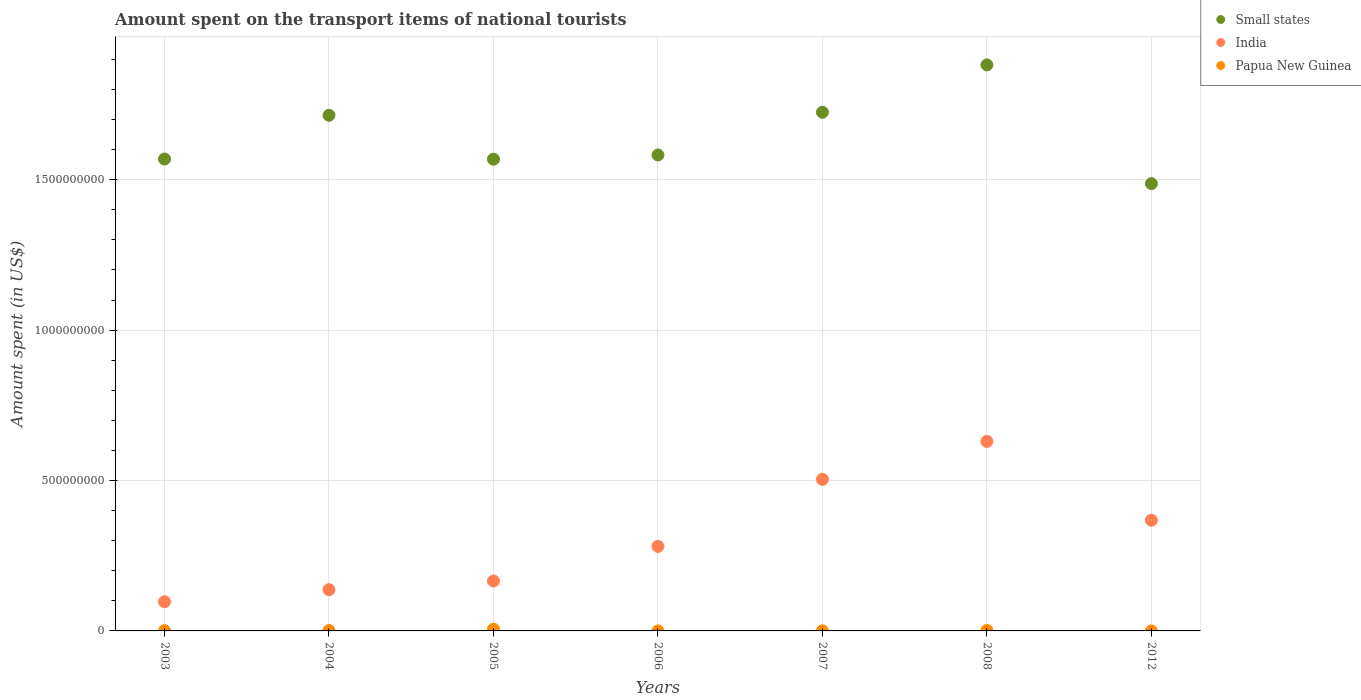What is the amount spent on the transport items of national tourists in India in 2008?
Your response must be concise. 6.30e+08. Across all years, what is the maximum amount spent on the transport items of national tourists in Papua New Guinea?
Give a very brief answer. 5.80e+06. Across all years, what is the minimum amount spent on the transport items of national tourists in Small states?
Provide a succinct answer. 1.49e+09. In which year was the amount spent on the transport items of national tourists in Small states minimum?
Offer a terse response. 2012. What is the total amount spent on the transport items of national tourists in Small states in the graph?
Your answer should be compact. 1.15e+1. What is the difference between the amount spent on the transport items of national tourists in India in 2006 and that in 2008?
Ensure brevity in your answer.  -3.49e+08. What is the difference between the amount spent on the transport items of national tourists in India in 2003 and the amount spent on the transport items of national tourists in Papua New Guinea in 2007?
Ensure brevity in your answer.  9.67e+07. What is the average amount spent on the transport items of national tourists in India per year?
Offer a very short reply. 3.12e+08. In the year 2005, what is the difference between the amount spent on the transport items of national tourists in Papua New Guinea and amount spent on the transport items of national tourists in India?
Offer a very short reply. -1.60e+08. In how many years, is the amount spent on the transport items of national tourists in Small states greater than 100000000 US$?
Provide a short and direct response. 7. What is the ratio of the amount spent on the transport items of national tourists in Small states in 2004 to that in 2006?
Your answer should be compact. 1.08. Is the difference between the amount spent on the transport items of national tourists in Papua New Guinea in 2007 and 2008 greater than the difference between the amount spent on the transport items of national tourists in India in 2007 and 2008?
Offer a very short reply. Yes. What is the difference between the highest and the second highest amount spent on the transport items of national tourists in Papua New Guinea?
Provide a short and direct response. 4.20e+06. What is the difference between the highest and the lowest amount spent on the transport items of national tourists in Papua New Guinea?
Provide a short and direct response. 5.77e+06. In how many years, is the amount spent on the transport items of national tourists in Papua New Guinea greater than the average amount spent on the transport items of national tourists in Papua New Guinea taken over all years?
Offer a very short reply. 2. Is it the case that in every year, the sum of the amount spent on the transport items of national tourists in Papua New Guinea and amount spent on the transport items of national tourists in India  is greater than the amount spent on the transport items of national tourists in Small states?
Provide a short and direct response. No. What is the difference between two consecutive major ticks on the Y-axis?
Provide a succinct answer. 5.00e+08. Are the values on the major ticks of Y-axis written in scientific E-notation?
Offer a terse response. No. Where does the legend appear in the graph?
Provide a succinct answer. Top right. How are the legend labels stacked?
Keep it short and to the point. Vertical. What is the title of the graph?
Provide a short and direct response. Amount spent on the transport items of national tourists. Does "Heavily indebted poor countries" appear as one of the legend labels in the graph?
Offer a terse response. No. What is the label or title of the Y-axis?
Ensure brevity in your answer.  Amount spent (in US$). What is the Amount spent (in US$) in Small states in 2003?
Offer a terse response. 1.57e+09. What is the Amount spent (in US$) in India in 2003?
Your answer should be very brief. 9.70e+07. What is the Amount spent (in US$) in Papua New Guinea in 2003?
Provide a short and direct response. 9.00e+05. What is the Amount spent (in US$) in Small states in 2004?
Make the answer very short. 1.71e+09. What is the Amount spent (in US$) of India in 2004?
Offer a terse response. 1.37e+08. What is the Amount spent (in US$) of Papua New Guinea in 2004?
Keep it short and to the point. 1.30e+06. What is the Amount spent (in US$) of Small states in 2005?
Offer a terse response. 1.57e+09. What is the Amount spent (in US$) of India in 2005?
Give a very brief answer. 1.66e+08. What is the Amount spent (in US$) of Papua New Guinea in 2005?
Keep it short and to the point. 5.80e+06. What is the Amount spent (in US$) in Small states in 2006?
Your answer should be compact. 1.58e+09. What is the Amount spent (in US$) of India in 2006?
Offer a very short reply. 2.81e+08. What is the Amount spent (in US$) of Papua New Guinea in 2006?
Offer a terse response. 3.00e+04. What is the Amount spent (in US$) of Small states in 2007?
Provide a succinct answer. 1.72e+09. What is the Amount spent (in US$) of India in 2007?
Your answer should be compact. 5.04e+08. What is the Amount spent (in US$) of Small states in 2008?
Your answer should be compact. 1.88e+09. What is the Amount spent (in US$) of India in 2008?
Ensure brevity in your answer.  6.30e+08. What is the Amount spent (in US$) of Papua New Guinea in 2008?
Your answer should be compact. 1.60e+06. What is the Amount spent (in US$) in Small states in 2012?
Provide a short and direct response. 1.49e+09. What is the Amount spent (in US$) in India in 2012?
Your response must be concise. 3.68e+08. Across all years, what is the maximum Amount spent (in US$) in Small states?
Keep it short and to the point. 1.88e+09. Across all years, what is the maximum Amount spent (in US$) of India?
Offer a terse response. 6.30e+08. Across all years, what is the maximum Amount spent (in US$) of Papua New Guinea?
Offer a very short reply. 5.80e+06. Across all years, what is the minimum Amount spent (in US$) of Small states?
Provide a short and direct response. 1.49e+09. Across all years, what is the minimum Amount spent (in US$) of India?
Keep it short and to the point. 9.70e+07. Across all years, what is the minimum Amount spent (in US$) of Papua New Guinea?
Offer a very short reply. 3.00e+04. What is the total Amount spent (in US$) of Small states in the graph?
Your answer should be compact. 1.15e+1. What is the total Amount spent (in US$) in India in the graph?
Give a very brief answer. 2.18e+09. What is the total Amount spent (in US$) in Papua New Guinea in the graph?
Provide a succinct answer. 1.00e+07. What is the difference between the Amount spent (in US$) of Small states in 2003 and that in 2004?
Offer a very short reply. -1.45e+08. What is the difference between the Amount spent (in US$) of India in 2003 and that in 2004?
Offer a very short reply. -4.00e+07. What is the difference between the Amount spent (in US$) in Papua New Guinea in 2003 and that in 2004?
Offer a very short reply. -4.00e+05. What is the difference between the Amount spent (in US$) of Small states in 2003 and that in 2005?
Ensure brevity in your answer.  5.74e+05. What is the difference between the Amount spent (in US$) of India in 2003 and that in 2005?
Give a very brief answer. -6.90e+07. What is the difference between the Amount spent (in US$) in Papua New Guinea in 2003 and that in 2005?
Keep it short and to the point. -4.90e+06. What is the difference between the Amount spent (in US$) in Small states in 2003 and that in 2006?
Keep it short and to the point. -1.35e+07. What is the difference between the Amount spent (in US$) of India in 2003 and that in 2006?
Ensure brevity in your answer.  -1.84e+08. What is the difference between the Amount spent (in US$) in Papua New Guinea in 2003 and that in 2006?
Your answer should be very brief. 8.70e+05. What is the difference between the Amount spent (in US$) in Small states in 2003 and that in 2007?
Your answer should be compact. -1.55e+08. What is the difference between the Amount spent (in US$) in India in 2003 and that in 2007?
Provide a succinct answer. -4.07e+08. What is the difference between the Amount spent (in US$) of Papua New Guinea in 2003 and that in 2007?
Your response must be concise. 6.00e+05. What is the difference between the Amount spent (in US$) of Small states in 2003 and that in 2008?
Keep it short and to the point. -3.13e+08. What is the difference between the Amount spent (in US$) in India in 2003 and that in 2008?
Offer a terse response. -5.33e+08. What is the difference between the Amount spent (in US$) in Papua New Guinea in 2003 and that in 2008?
Make the answer very short. -7.00e+05. What is the difference between the Amount spent (in US$) of Small states in 2003 and that in 2012?
Provide a short and direct response. 8.17e+07. What is the difference between the Amount spent (in US$) of India in 2003 and that in 2012?
Ensure brevity in your answer.  -2.71e+08. What is the difference between the Amount spent (in US$) in Papua New Guinea in 2003 and that in 2012?
Provide a short and direct response. 8.00e+05. What is the difference between the Amount spent (in US$) in Small states in 2004 and that in 2005?
Keep it short and to the point. 1.46e+08. What is the difference between the Amount spent (in US$) of India in 2004 and that in 2005?
Your response must be concise. -2.90e+07. What is the difference between the Amount spent (in US$) of Papua New Guinea in 2004 and that in 2005?
Ensure brevity in your answer.  -4.50e+06. What is the difference between the Amount spent (in US$) of Small states in 2004 and that in 2006?
Provide a short and direct response. 1.32e+08. What is the difference between the Amount spent (in US$) in India in 2004 and that in 2006?
Ensure brevity in your answer.  -1.44e+08. What is the difference between the Amount spent (in US$) in Papua New Guinea in 2004 and that in 2006?
Provide a succinct answer. 1.27e+06. What is the difference between the Amount spent (in US$) of Small states in 2004 and that in 2007?
Offer a terse response. -9.98e+06. What is the difference between the Amount spent (in US$) of India in 2004 and that in 2007?
Your answer should be very brief. -3.67e+08. What is the difference between the Amount spent (in US$) of Papua New Guinea in 2004 and that in 2007?
Offer a very short reply. 1.00e+06. What is the difference between the Amount spent (in US$) in Small states in 2004 and that in 2008?
Offer a terse response. -1.68e+08. What is the difference between the Amount spent (in US$) in India in 2004 and that in 2008?
Your response must be concise. -4.93e+08. What is the difference between the Amount spent (in US$) in Small states in 2004 and that in 2012?
Ensure brevity in your answer.  2.27e+08. What is the difference between the Amount spent (in US$) of India in 2004 and that in 2012?
Make the answer very short. -2.31e+08. What is the difference between the Amount spent (in US$) of Papua New Guinea in 2004 and that in 2012?
Your answer should be compact. 1.20e+06. What is the difference between the Amount spent (in US$) of Small states in 2005 and that in 2006?
Keep it short and to the point. -1.40e+07. What is the difference between the Amount spent (in US$) of India in 2005 and that in 2006?
Make the answer very short. -1.15e+08. What is the difference between the Amount spent (in US$) in Papua New Guinea in 2005 and that in 2006?
Give a very brief answer. 5.77e+06. What is the difference between the Amount spent (in US$) in Small states in 2005 and that in 2007?
Offer a very short reply. -1.56e+08. What is the difference between the Amount spent (in US$) in India in 2005 and that in 2007?
Provide a succinct answer. -3.38e+08. What is the difference between the Amount spent (in US$) of Papua New Guinea in 2005 and that in 2007?
Offer a very short reply. 5.50e+06. What is the difference between the Amount spent (in US$) in Small states in 2005 and that in 2008?
Offer a very short reply. -3.14e+08. What is the difference between the Amount spent (in US$) of India in 2005 and that in 2008?
Keep it short and to the point. -4.64e+08. What is the difference between the Amount spent (in US$) in Papua New Guinea in 2005 and that in 2008?
Provide a succinct answer. 4.20e+06. What is the difference between the Amount spent (in US$) in Small states in 2005 and that in 2012?
Provide a short and direct response. 8.11e+07. What is the difference between the Amount spent (in US$) in India in 2005 and that in 2012?
Ensure brevity in your answer.  -2.02e+08. What is the difference between the Amount spent (in US$) in Papua New Guinea in 2005 and that in 2012?
Ensure brevity in your answer.  5.70e+06. What is the difference between the Amount spent (in US$) of Small states in 2006 and that in 2007?
Keep it short and to the point. -1.42e+08. What is the difference between the Amount spent (in US$) of India in 2006 and that in 2007?
Your answer should be very brief. -2.23e+08. What is the difference between the Amount spent (in US$) of Small states in 2006 and that in 2008?
Offer a terse response. -3.00e+08. What is the difference between the Amount spent (in US$) of India in 2006 and that in 2008?
Your answer should be compact. -3.49e+08. What is the difference between the Amount spent (in US$) of Papua New Guinea in 2006 and that in 2008?
Offer a very short reply. -1.57e+06. What is the difference between the Amount spent (in US$) of Small states in 2006 and that in 2012?
Make the answer very short. 9.52e+07. What is the difference between the Amount spent (in US$) in India in 2006 and that in 2012?
Provide a short and direct response. -8.70e+07. What is the difference between the Amount spent (in US$) of Papua New Guinea in 2006 and that in 2012?
Provide a succinct answer. -7.00e+04. What is the difference between the Amount spent (in US$) of Small states in 2007 and that in 2008?
Make the answer very short. -1.58e+08. What is the difference between the Amount spent (in US$) of India in 2007 and that in 2008?
Ensure brevity in your answer.  -1.26e+08. What is the difference between the Amount spent (in US$) of Papua New Guinea in 2007 and that in 2008?
Keep it short and to the point. -1.30e+06. What is the difference between the Amount spent (in US$) in Small states in 2007 and that in 2012?
Your response must be concise. 2.37e+08. What is the difference between the Amount spent (in US$) of India in 2007 and that in 2012?
Ensure brevity in your answer.  1.36e+08. What is the difference between the Amount spent (in US$) of Small states in 2008 and that in 2012?
Your answer should be very brief. 3.95e+08. What is the difference between the Amount spent (in US$) in India in 2008 and that in 2012?
Offer a very short reply. 2.62e+08. What is the difference between the Amount spent (in US$) of Papua New Guinea in 2008 and that in 2012?
Your answer should be compact. 1.50e+06. What is the difference between the Amount spent (in US$) in Small states in 2003 and the Amount spent (in US$) in India in 2004?
Give a very brief answer. 1.43e+09. What is the difference between the Amount spent (in US$) of Small states in 2003 and the Amount spent (in US$) of Papua New Guinea in 2004?
Provide a succinct answer. 1.57e+09. What is the difference between the Amount spent (in US$) in India in 2003 and the Amount spent (in US$) in Papua New Guinea in 2004?
Keep it short and to the point. 9.57e+07. What is the difference between the Amount spent (in US$) in Small states in 2003 and the Amount spent (in US$) in India in 2005?
Your answer should be very brief. 1.40e+09. What is the difference between the Amount spent (in US$) of Small states in 2003 and the Amount spent (in US$) of Papua New Guinea in 2005?
Provide a succinct answer. 1.56e+09. What is the difference between the Amount spent (in US$) in India in 2003 and the Amount spent (in US$) in Papua New Guinea in 2005?
Offer a terse response. 9.12e+07. What is the difference between the Amount spent (in US$) of Small states in 2003 and the Amount spent (in US$) of India in 2006?
Your response must be concise. 1.29e+09. What is the difference between the Amount spent (in US$) of Small states in 2003 and the Amount spent (in US$) of Papua New Guinea in 2006?
Provide a succinct answer. 1.57e+09. What is the difference between the Amount spent (in US$) in India in 2003 and the Amount spent (in US$) in Papua New Guinea in 2006?
Your answer should be compact. 9.70e+07. What is the difference between the Amount spent (in US$) of Small states in 2003 and the Amount spent (in US$) of India in 2007?
Ensure brevity in your answer.  1.06e+09. What is the difference between the Amount spent (in US$) in Small states in 2003 and the Amount spent (in US$) in Papua New Guinea in 2007?
Provide a succinct answer. 1.57e+09. What is the difference between the Amount spent (in US$) of India in 2003 and the Amount spent (in US$) of Papua New Guinea in 2007?
Make the answer very short. 9.67e+07. What is the difference between the Amount spent (in US$) of Small states in 2003 and the Amount spent (in US$) of India in 2008?
Offer a terse response. 9.39e+08. What is the difference between the Amount spent (in US$) in Small states in 2003 and the Amount spent (in US$) in Papua New Guinea in 2008?
Make the answer very short. 1.57e+09. What is the difference between the Amount spent (in US$) in India in 2003 and the Amount spent (in US$) in Papua New Guinea in 2008?
Your response must be concise. 9.54e+07. What is the difference between the Amount spent (in US$) of Small states in 2003 and the Amount spent (in US$) of India in 2012?
Your answer should be compact. 1.20e+09. What is the difference between the Amount spent (in US$) in Small states in 2003 and the Amount spent (in US$) in Papua New Guinea in 2012?
Offer a terse response. 1.57e+09. What is the difference between the Amount spent (in US$) of India in 2003 and the Amount spent (in US$) of Papua New Guinea in 2012?
Provide a short and direct response. 9.69e+07. What is the difference between the Amount spent (in US$) in Small states in 2004 and the Amount spent (in US$) in India in 2005?
Your answer should be compact. 1.55e+09. What is the difference between the Amount spent (in US$) of Small states in 2004 and the Amount spent (in US$) of Papua New Guinea in 2005?
Keep it short and to the point. 1.71e+09. What is the difference between the Amount spent (in US$) of India in 2004 and the Amount spent (in US$) of Papua New Guinea in 2005?
Provide a succinct answer. 1.31e+08. What is the difference between the Amount spent (in US$) of Small states in 2004 and the Amount spent (in US$) of India in 2006?
Offer a very short reply. 1.43e+09. What is the difference between the Amount spent (in US$) in Small states in 2004 and the Amount spent (in US$) in Papua New Guinea in 2006?
Your answer should be very brief. 1.71e+09. What is the difference between the Amount spent (in US$) in India in 2004 and the Amount spent (in US$) in Papua New Guinea in 2006?
Your response must be concise. 1.37e+08. What is the difference between the Amount spent (in US$) of Small states in 2004 and the Amount spent (in US$) of India in 2007?
Make the answer very short. 1.21e+09. What is the difference between the Amount spent (in US$) in Small states in 2004 and the Amount spent (in US$) in Papua New Guinea in 2007?
Your answer should be very brief. 1.71e+09. What is the difference between the Amount spent (in US$) in India in 2004 and the Amount spent (in US$) in Papua New Guinea in 2007?
Give a very brief answer. 1.37e+08. What is the difference between the Amount spent (in US$) of Small states in 2004 and the Amount spent (in US$) of India in 2008?
Your answer should be very brief. 1.08e+09. What is the difference between the Amount spent (in US$) of Small states in 2004 and the Amount spent (in US$) of Papua New Guinea in 2008?
Give a very brief answer. 1.71e+09. What is the difference between the Amount spent (in US$) in India in 2004 and the Amount spent (in US$) in Papua New Guinea in 2008?
Keep it short and to the point. 1.35e+08. What is the difference between the Amount spent (in US$) of Small states in 2004 and the Amount spent (in US$) of India in 2012?
Your answer should be very brief. 1.35e+09. What is the difference between the Amount spent (in US$) in Small states in 2004 and the Amount spent (in US$) in Papua New Guinea in 2012?
Make the answer very short. 1.71e+09. What is the difference between the Amount spent (in US$) of India in 2004 and the Amount spent (in US$) of Papua New Guinea in 2012?
Give a very brief answer. 1.37e+08. What is the difference between the Amount spent (in US$) of Small states in 2005 and the Amount spent (in US$) of India in 2006?
Ensure brevity in your answer.  1.29e+09. What is the difference between the Amount spent (in US$) of Small states in 2005 and the Amount spent (in US$) of Papua New Guinea in 2006?
Your answer should be compact. 1.57e+09. What is the difference between the Amount spent (in US$) of India in 2005 and the Amount spent (in US$) of Papua New Guinea in 2006?
Your answer should be very brief. 1.66e+08. What is the difference between the Amount spent (in US$) of Small states in 2005 and the Amount spent (in US$) of India in 2007?
Your answer should be compact. 1.06e+09. What is the difference between the Amount spent (in US$) of Small states in 2005 and the Amount spent (in US$) of Papua New Guinea in 2007?
Offer a terse response. 1.57e+09. What is the difference between the Amount spent (in US$) in India in 2005 and the Amount spent (in US$) in Papua New Guinea in 2007?
Ensure brevity in your answer.  1.66e+08. What is the difference between the Amount spent (in US$) of Small states in 2005 and the Amount spent (in US$) of India in 2008?
Give a very brief answer. 9.38e+08. What is the difference between the Amount spent (in US$) of Small states in 2005 and the Amount spent (in US$) of Papua New Guinea in 2008?
Provide a short and direct response. 1.57e+09. What is the difference between the Amount spent (in US$) of India in 2005 and the Amount spent (in US$) of Papua New Guinea in 2008?
Offer a very short reply. 1.64e+08. What is the difference between the Amount spent (in US$) of Small states in 2005 and the Amount spent (in US$) of India in 2012?
Your answer should be very brief. 1.20e+09. What is the difference between the Amount spent (in US$) in Small states in 2005 and the Amount spent (in US$) in Papua New Guinea in 2012?
Your response must be concise. 1.57e+09. What is the difference between the Amount spent (in US$) in India in 2005 and the Amount spent (in US$) in Papua New Guinea in 2012?
Provide a short and direct response. 1.66e+08. What is the difference between the Amount spent (in US$) of Small states in 2006 and the Amount spent (in US$) of India in 2007?
Offer a very short reply. 1.08e+09. What is the difference between the Amount spent (in US$) of Small states in 2006 and the Amount spent (in US$) of Papua New Guinea in 2007?
Your answer should be very brief. 1.58e+09. What is the difference between the Amount spent (in US$) of India in 2006 and the Amount spent (in US$) of Papua New Guinea in 2007?
Offer a very short reply. 2.81e+08. What is the difference between the Amount spent (in US$) of Small states in 2006 and the Amount spent (in US$) of India in 2008?
Provide a short and direct response. 9.52e+08. What is the difference between the Amount spent (in US$) of Small states in 2006 and the Amount spent (in US$) of Papua New Guinea in 2008?
Your answer should be compact. 1.58e+09. What is the difference between the Amount spent (in US$) in India in 2006 and the Amount spent (in US$) in Papua New Guinea in 2008?
Provide a succinct answer. 2.79e+08. What is the difference between the Amount spent (in US$) of Small states in 2006 and the Amount spent (in US$) of India in 2012?
Offer a terse response. 1.21e+09. What is the difference between the Amount spent (in US$) in Small states in 2006 and the Amount spent (in US$) in Papua New Guinea in 2012?
Keep it short and to the point. 1.58e+09. What is the difference between the Amount spent (in US$) in India in 2006 and the Amount spent (in US$) in Papua New Guinea in 2012?
Your response must be concise. 2.81e+08. What is the difference between the Amount spent (in US$) in Small states in 2007 and the Amount spent (in US$) in India in 2008?
Offer a terse response. 1.09e+09. What is the difference between the Amount spent (in US$) in Small states in 2007 and the Amount spent (in US$) in Papua New Guinea in 2008?
Ensure brevity in your answer.  1.72e+09. What is the difference between the Amount spent (in US$) in India in 2007 and the Amount spent (in US$) in Papua New Guinea in 2008?
Offer a terse response. 5.02e+08. What is the difference between the Amount spent (in US$) of Small states in 2007 and the Amount spent (in US$) of India in 2012?
Offer a terse response. 1.36e+09. What is the difference between the Amount spent (in US$) in Small states in 2007 and the Amount spent (in US$) in Papua New Guinea in 2012?
Provide a succinct answer. 1.72e+09. What is the difference between the Amount spent (in US$) of India in 2007 and the Amount spent (in US$) of Papua New Guinea in 2012?
Provide a succinct answer. 5.04e+08. What is the difference between the Amount spent (in US$) in Small states in 2008 and the Amount spent (in US$) in India in 2012?
Your response must be concise. 1.51e+09. What is the difference between the Amount spent (in US$) in Small states in 2008 and the Amount spent (in US$) in Papua New Guinea in 2012?
Your answer should be very brief. 1.88e+09. What is the difference between the Amount spent (in US$) of India in 2008 and the Amount spent (in US$) of Papua New Guinea in 2012?
Provide a succinct answer. 6.30e+08. What is the average Amount spent (in US$) of Small states per year?
Make the answer very short. 1.65e+09. What is the average Amount spent (in US$) in India per year?
Provide a short and direct response. 3.12e+08. What is the average Amount spent (in US$) of Papua New Guinea per year?
Make the answer very short. 1.43e+06. In the year 2003, what is the difference between the Amount spent (in US$) of Small states and Amount spent (in US$) of India?
Give a very brief answer. 1.47e+09. In the year 2003, what is the difference between the Amount spent (in US$) of Small states and Amount spent (in US$) of Papua New Guinea?
Offer a terse response. 1.57e+09. In the year 2003, what is the difference between the Amount spent (in US$) in India and Amount spent (in US$) in Papua New Guinea?
Ensure brevity in your answer.  9.61e+07. In the year 2004, what is the difference between the Amount spent (in US$) of Small states and Amount spent (in US$) of India?
Make the answer very short. 1.58e+09. In the year 2004, what is the difference between the Amount spent (in US$) of Small states and Amount spent (in US$) of Papua New Guinea?
Provide a short and direct response. 1.71e+09. In the year 2004, what is the difference between the Amount spent (in US$) in India and Amount spent (in US$) in Papua New Guinea?
Offer a very short reply. 1.36e+08. In the year 2005, what is the difference between the Amount spent (in US$) in Small states and Amount spent (in US$) in India?
Provide a succinct answer. 1.40e+09. In the year 2005, what is the difference between the Amount spent (in US$) in Small states and Amount spent (in US$) in Papua New Guinea?
Your answer should be very brief. 1.56e+09. In the year 2005, what is the difference between the Amount spent (in US$) of India and Amount spent (in US$) of Papua New Guinea?
Offer a very short reply. 1.60e+08. In the year 2006, what is the difference between the Amount spent (in US$) in Small states and Amount spent (in US$) in India?
Make the answer very short. 1.30e+09. In the year 2006, what is the difference between the Amount spent (in US$) in Small states and Amount spent (in US$) in Papua New Guinea?
Provide a short and direct response. 1.58e+09. In the year 2006, what is the difference between the Amount spent (in US$) in India and Amount spent (in US$) in Papua New Guinea?
Offer a terse response. 2.81e+08. In the year 2007, what is the difference between the Amount spent (in US$) in Small states and Amount spent (in US$) in India?
Your answer should be very brief. 1.22e+09. In the year 2007, what is the difference between the Amount spent (in US$) in Small states and Amount spent (in US$) in Papua New Guinea?
Your answer should be compact. 1.72e+09. In the year 2007, what is the difference between the Amount spent (in US$) in India and Amount spent (in US$) in Papua New Guinea?
Provide a succinct answer. 5.04e+08. In the year 2008, what is the difference between the Amount spent (in US$) in Small states and Amount spent (in US$) in India?
Keep it short and to the point. 1.25e+09. In the year 2008, what is the difference between the Amount spent (in US$) in Small states and Amount spent (in US$) in Papua New Guinea?
Your answer should be compact. 1.88e+09. In the year 2008, what is the difference between the Amount spent (in US$) in India and Amount spent (in US$) in Papua New Guinea?
Provide a succinct answer. 6.28e+08. In the year 2012, what is the difference between the Amount spent (in US$) of Small states and Amount spent (in US$) of India?
Your response must be concise. 1.12e+09. In the year 2012, what is the difference between the Amount spent (in US$) of Small states and Amount spent (in US$) of Papua New Guinea?
Offer a very short reply. 1.49e+09. In the year 2012, what is the difference between the Amount spent (in US$) in India and Amount spent (in US$) in Papua New Guinea?
Your answer should be compact. 3.68e+08. What is the ratio of the Amount spent (in US$) in Small states in 2003 to that in 2004?
Your answer should be compact. 0.92. What is the ratio of the Amount spent (in US$) in India in 2003 to that in 2004?
Provide a short and direct response. 0.71. What is the ratio of the Amount spent (in US$) of Papua New Guinea in 2003 to that in 2004?
Offer a very short reply. 0.69. What is the ratio of the Amount spent (in US$) of India in 2003 to that in 2005?
Your response must be concise. 0.58. What is the ratio of the Amount spent (in US$) in Papua New Guinea in 2003 to that in 2005?
Make the answer very short. 0.16. What is the ratio of the Amount spent (in US$) of Small states in 2003 to that in 2006?
Offer a terse response. 0.99. What is the ratio of the Amount spent (in US$) of India in 2003 to that in 2006?
Keep it short and to the point. 0.35. What is the ratio of the Amount spent (in US$) of Papua New Guinea in 2003 to that in 2006?
Keep it short and to the point. 30. What is the ratio of the Amount spent (in US$) in Small states in 2003 to that in 2007?
Offer a terse response. 0.91. What is the ratio of the Amount spent (in US$) in India in 2003 to that in 2007?
Offer a terse response. 0.19. What is the ratio of the Amount spent (in US$) in Papua New Guinea in 2003 to that in 2007?
Your answer should be compact. 3. What is the ratio of the Amount spent (in US$) of Small states in 2003 to that in 2008?
Keep it short and to the point. 0.83. What is the ratio of the Amount spent (in US$) in India in 2003 to that in 2008?
Offer a terse response. 0.15. What is the ratio of the Amount spent (in US$) in Papua New Guinea in 2003 to that in 2008?
Your response must be concise. 0.56. What is the ratio of the Amount spent (in US$) in Small states in 2003 to that in 2012?
Give a very brief answer. 1.05. What is the ratio of the Amount spent (in US$) of India in 2003 to that in 2012?
Make the answer very short. 0.26. What is the ratio of the Amount spent (in US$) of Papua New Guinea in 2003 to that in 2012?
Ensure brevity in your answer.  9. What is the ratio of the Amount spent (in US$) in Small states in 2004 to that in 2005?
Your answer should be compact. 1.09. What is the ratio of the Amount spent (in US$) of India in 2004 to that in 2005?
Your answer should be very brief. 0.83. What is the ratio of the Amount spent (in US$) in Papua New Guinea in 2004 to that in 2005?
Offer a terse response. 0.22. What is the ratio of the Amount spent (in US$) of Small states in 2004 to that in 2006?
Your answer should be compact. 1.08. What is the ratio of the Amount spent (in US$) in India in 2004 to that in 2006?
Provide a succinct answer. 0.49. What is the ratio of the Amount spent (in US$) in Papua New Guinea in 2004 to that in 2006?
Make the answer very short. 43.33. What is the ratio of the Amount spent (in US$) of India in 2004 to that in 2007?
Offer a terse response. 0.27. What is the ratio of the Amount spent (in US$) of Papua New Guinea in 2004 to that in 2007?
Give a very brief answer. 4.33. What is the ratio of the Amount spent (in US$) of Small states in 2004 to that in 2008?
Your response must be concise. 0.91. What is the ratio of the Amount spent (in US$) of India in 2004 to that in 2008?
Give a very brief answer. 0.22. What is the ratio of the Amount spent (in US$) in Papua New Guinea in 2004 to that in 2008?
Your answer should be compact. 0.81. What is the ratio of the Amount spent (in US$) of Small states in 2004 to that in 2012?
Your response must be concise. 1.15. What is the ratio of the Amount spent (in US$) of India in 2004 to that in 2012?
Your answer should be compact. 0.37. What is the ratio of the Amount spent (in US$) in Papua New Guinea in 2004 to that in 2012?
Offer a very short reply. 13. What is the ratio of the Amount spent (in US$) in India in 2005 to that in 2006?
Your response must be concise. 0.59. What is the ratio of the Amount spent (in US$) in Papua New Guinea in 2005 to that in 2006?
Provide a succinct answer. 193.33. What is the ratio of the Amount spent (in US$) of Small states in 2005 to that in 2007?
Keep it short and to the point. 0.91. What is the ratio of the Amount spent (in US$) of India in 2005 to that in 2007?
Your answer should be very brief. 0.33. What is the ratio of the Amount spent (in US$) in Papua New Guinea in 2005 to that in 2007?
Offer a terse response. 19.33. What is the ratio of the Amount spent (in US$) of Small states in 2005 to that in 2008?
Keep it short and to the point. 0.83. What is the ratio of the Amount spent (in US$) of India in 2005 to that in 2008?
Make the answer very short. 0.26. What is the ratio of the Amount spent (in US$) in Papua New Guinea in 2005 to that in 2008?
Offer a terse response. 3.62. What is the ratio of the Amount spent (in US$) in Small states in 2005 to that in 2012?
Ensure brevity in your answer.  1.05. What is the ratio of the Amount spent (in US$) in India in 2005 to that in 2012?
Offer a terse response. 0.45. What is the ratio of the Amount spent (in US$) of Small states in 2006 to that in 2007?
Your response must be concise. 0.92. What is the ratio of the Amount spent (in US$) of India in 2006 to that in 2007?
Offer a very short reply. 0.56. What is the ratio of the Amount spent (in US$) in Small states in 2006 to that in 2008?
Your response must be concise. 0.84. What is the ratio of the Amount spent (in US$) in India in 2006 to that in 2008?
Offer a terse response. 0.45. What is the ratio of the Amount spent (in US$) in Papua New Guinea in 2006 to that in 2008?
Your response must be concise. 0.02. What is the ratio of the Amount spent (in US$) of Small states in 2006 to that in 2012?
Offer a terse response. 1.06. What is the ratio of the Amount spent (in US$) in India in 2006 to that in 2012?
Keep it short and to the point. 0.76. What is the ratio of the Amount spent (in US$) of Papua New Guinea in 2006 to that in 2012?
Offer a terse response. 0.3. What is the ratio of the Amount spent (in US$) in Small states in 2007 to that in 2008?
Provide a short and direct response. 0.92. What is the ratio of the Amount spent (in US$) in India in 2007 to that in 2008?
Offer a terse response. 0.8. What is the ratio of the Amount spent (in US$) in Papua New Guinea in 2007 to that in 2008?
Ensure brevity in your answer.  0.19. What is the ratio of the Amount spent (in US$) of Small states in 2007 to that in 2012?
Make the answer very short. 1.16. What is the ratio of the Amount spent (in US$) in India in 2007 to that in 2012?
Give a very brief answer. 1.37. What is the ratio of the Amount spent (in US$) of Papua New Guinea in 2007 to that in 2012?
Your response must be concise. 3. What is the ratio of the Amount spent (in US$) in Small states in 2008 to that in 2012?
Ensure brevity in your answer.  1.27. What is the ratio of the Amount spent (in US$) of India in 2008 to that in 2012?
Your answer should be compact. 1.71. What is the ratio of the Amount spent (in US$) of Papua New Guinea in 2008 to that in 2012?
Your response must be concise. 16. What is the difference between the highest and the second highest Amount spent (in US$) of Small states?
Make the answer very short. 1.58e+08. What is the difference between the highest and the second highest Amount spent (in US$) of India?
Provide a succinct answer. 1.26e+08. What is the difference between the highest and the second highest Amount spent (in US$) in Papua New Guinea?
Provide a short and direct response. 4.20e+06. What is the difference between the highest and the lowest Amount spent (in US$) of Small states?
Your answer should be very brief. 3.95e+08. What is the difference between the highest and the lowest Amount spent (in US$) in India?
Ensure brevity in your answer.  5.33e+08. What is the difference between the highest and the lowest Amount spent (in US$) in Papua New Guinea?
Make the answer very short. 5.77e+06. 